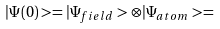<formula> <loc_0><loc_0><loc_500><loc_500>| \Psi ( 0 ) > = | \Psi _ { f i e l d } > \otimes | \Psi _ { a t o m } > =</formula> 